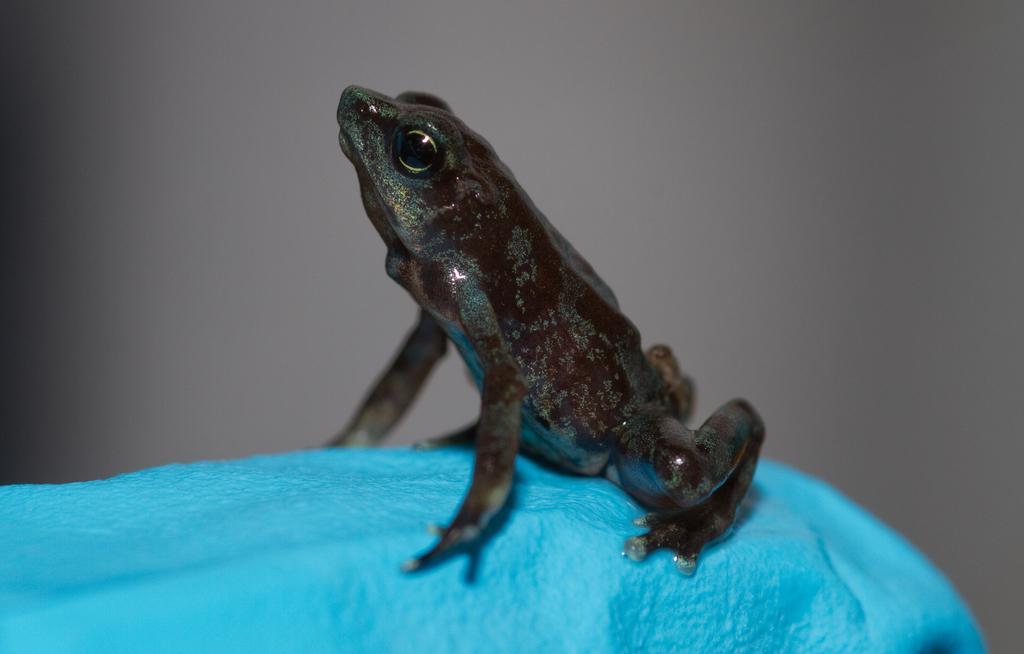Can you describe this image briefly? In the center of the image there is frog. 